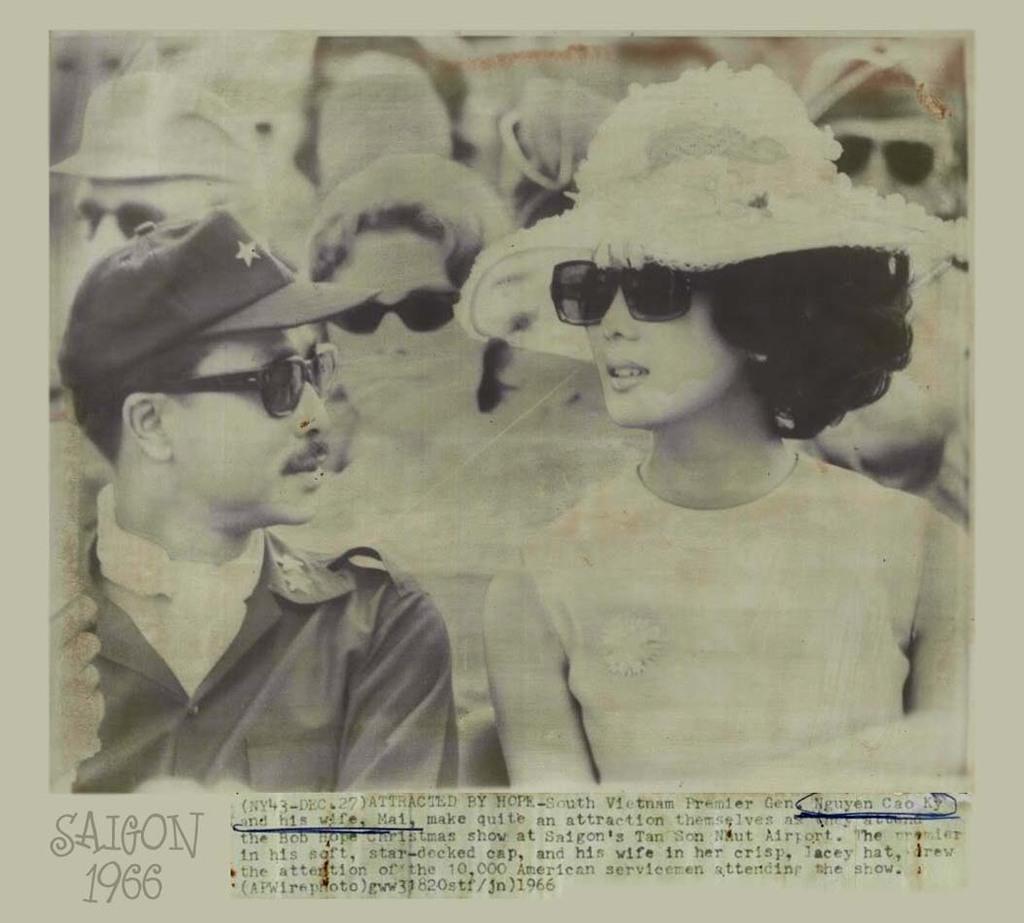Describe this image in one or two sentences. In this image, we can see an article. Here we can see a black and white picture. In this picture, we can see few people. 